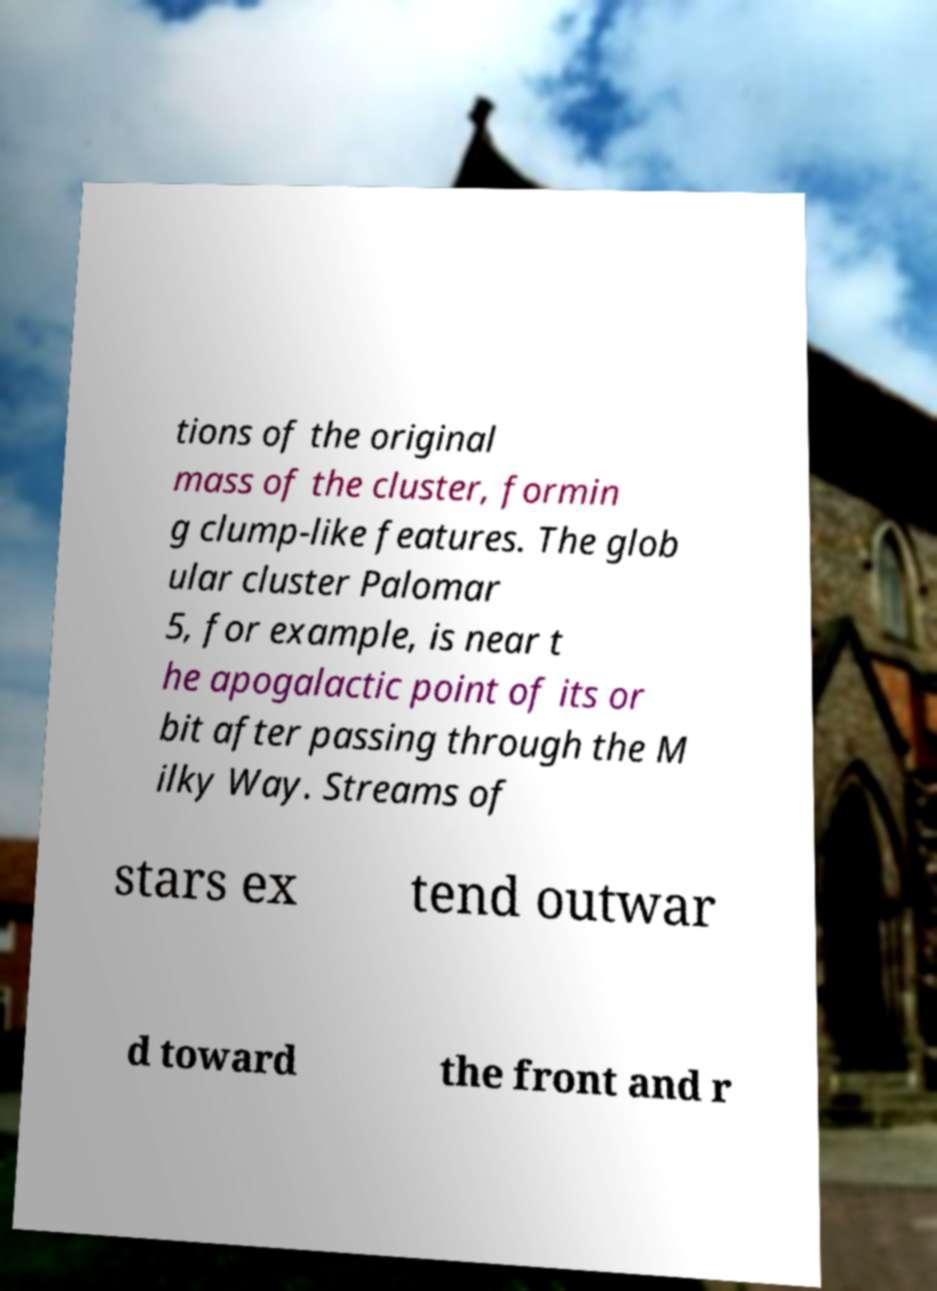Could you assist in decoding the text presented in this image and type it out clearly? tions of the original mass of the cluster, formin g clump-like features. The glob ular cluster Palomar 5, for example, is near t he apogalactic point of its or bit after passing through the M ilky Way. Streams of stars ex tend outwar d toward the front and r 